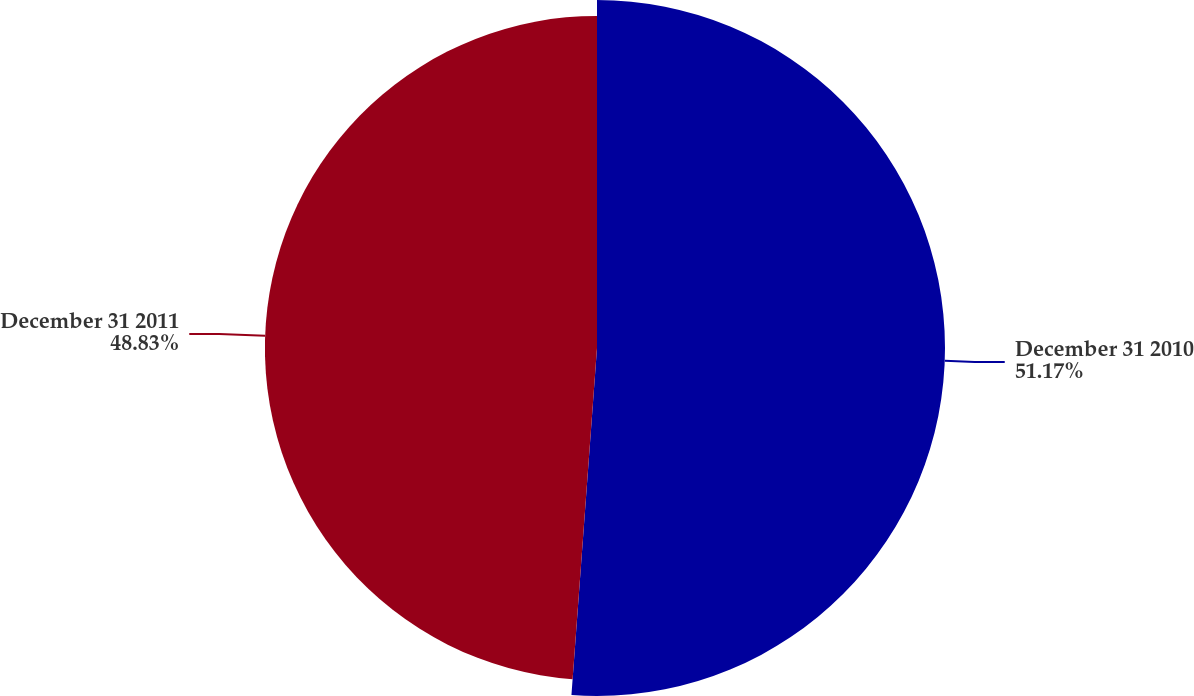Convert chart to OTSL. <chart><loc_0><loc_0><loc_500><loc_500><pie_chart><fcel>December 31 2010<fcel>December 31 2011<nl><fcel>51.17%<fcel>48.83%<nl></chart> 